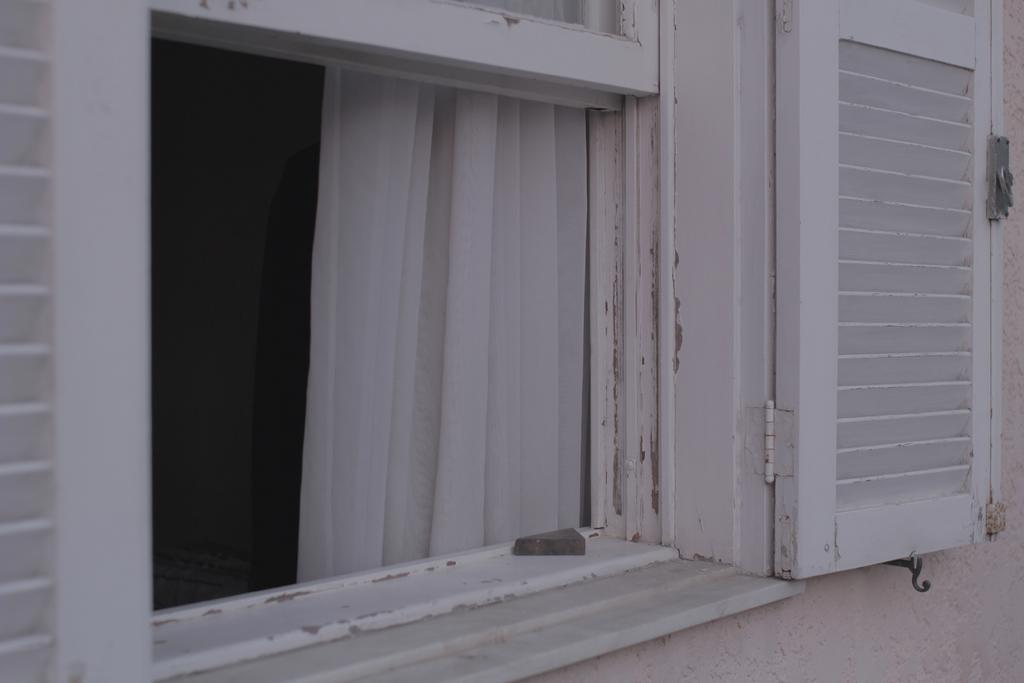What type of opening is present in the image? There is a window with a door in the image. What is covering the window? A curtain is hanging through the window. What part of the structure is visible at the bottom of the image? The wall is visible at the bottom of the image. What type of flower can be seen growing on the camp in the image? There is no camp or flower present in the image. 